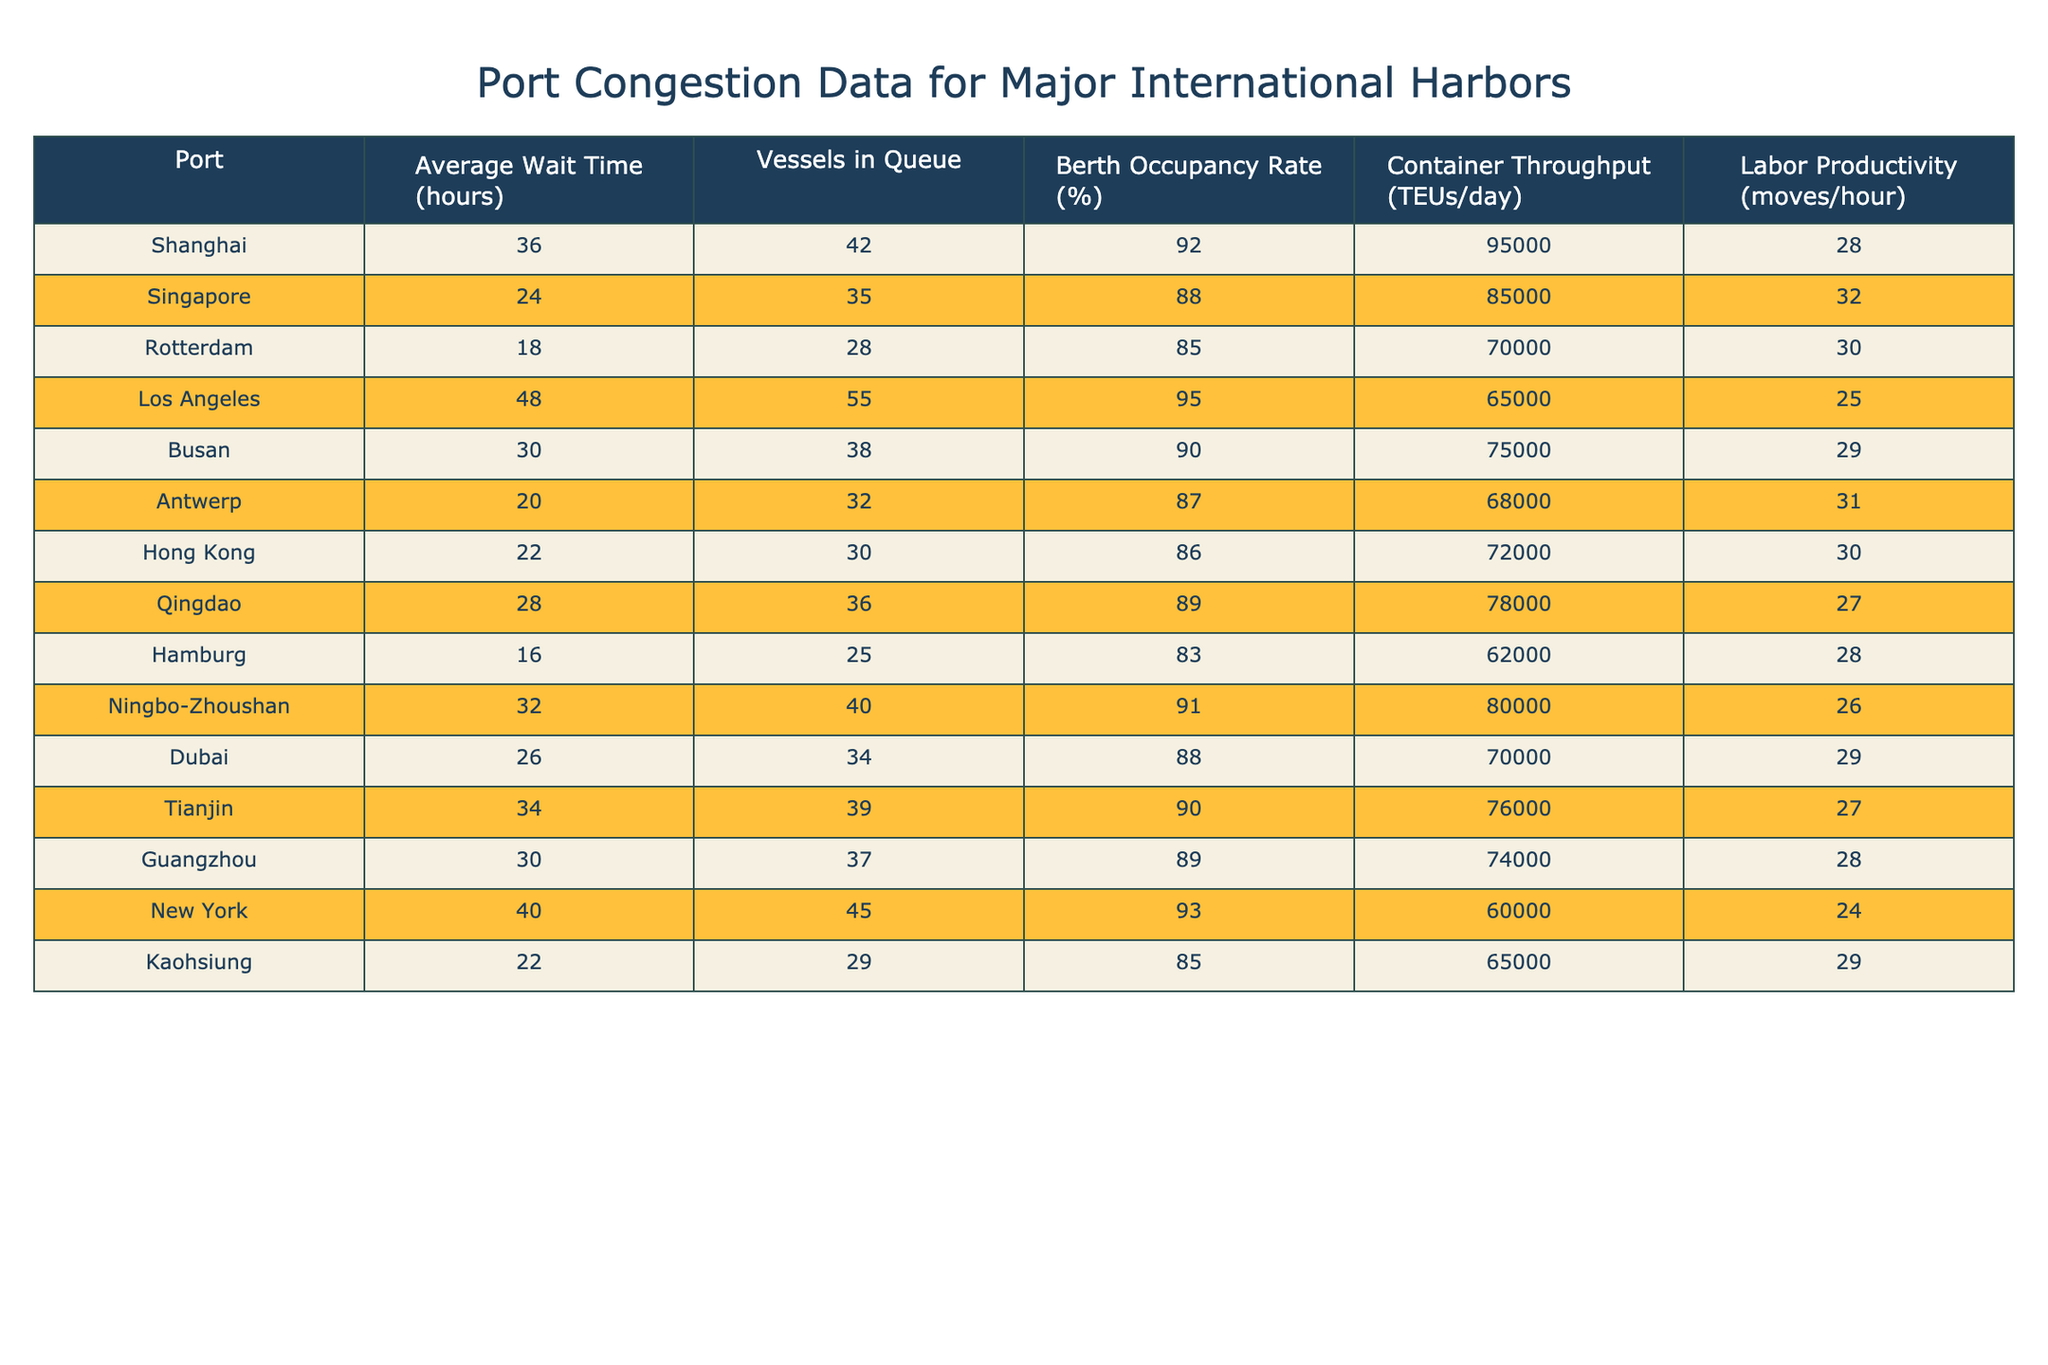What is the average wait time at Los Angeles port? From the table, the average wait time at Los Angeles is clearly listed as 48 hours.
Answer: 48 hours Which port has the highest rate of berth occupancy? By comparing the 'Berth Occupancy Rate (%)' column, Shanghai has the highest rate at 92%.
Answer: Shanghai How many vessels are queued at Antwerp? The number of vessels in queue at Antwerp is stated directly in the table as 32.
Answer: 32 What is the combined average wait time of Shanghai and Singapore ports? The average wait times for Shanghai and Singapore are 36 and 24 hours, respectively. Adding these gives 36 + 24 = 60 hours. To find the average, divide by 2, which results in 30 hours.
Answer: 30 hours Is the labor productivity higher in Rotterdam compared to Hamburg? The labor productivity at Rotterdam is listed as 30 moves/hour and at Hamburg as 28 moves/hour. Since 30 is greater than 28, the answer is yes.
Answer: Yes Which port has the second lowest berth occupancy rate? The berth occupancy rates for the ports in order are as follows: Hong Kong (86%), Antwerp (87%), and Rotterdam (85%). Therefore, Rotterdam has the second lowest rate after Hong Kong.
Answer: Rotterdam What is the total container throughput (in TEUs/day) of the three busiest ports: Shanghai, Singapore, and Los Angeles? The container throughputs for the three ports are 95000, 85000, and 65000 TEUs/day, respectively. Adding these gives 95000 + 85000 + 65000 = 245000 TEUs/day.
Answer: 245000 TEUs/day What percentage of ports have an average wait time greater than 30 hours? The ports with wait times greater than 30 hours are Shanghai, Los Angeles, Busan, Ningbo-Zhoushan, and Tianjin, which totals 5 ports. There are 14 ports in total, so the percentage is (5/14) * 100 = approximately 35.71%.
Answer: Approximately 35.71% Which port has the lowest number of vessels in queue? By looking at the 'Vessels in Queue' column, Hamburg has the lowest number with 25 vessels.
Answer: Hamburg How does the labor productivity at New York compare to the average labor productivity of all ports? The labor productivity in New York is 24 moves/hour. To find the average for all ports: (28 + 32 + 30 + 25 + 29 + 31 + 30 + 27 + 28 + 26 + 29 + 27 + 28 + 24) / 14 = 28. Therefore, New York's productivity is lower than average.
Answer: Lower than average What is the average container throughput of the three ports with the highest berth occupancy rates? The three ports with the highest berth occupancy rates are Shanghai (95000), Los Angeles (65000), and Ningbo-Zhoushan (80000). Adding these throughputs gives 95000 + 65000 + 80000 = 240000. Average = 240000 / 3 = 80000 TEUs/day.
Answer: 80000 TEUs/day 